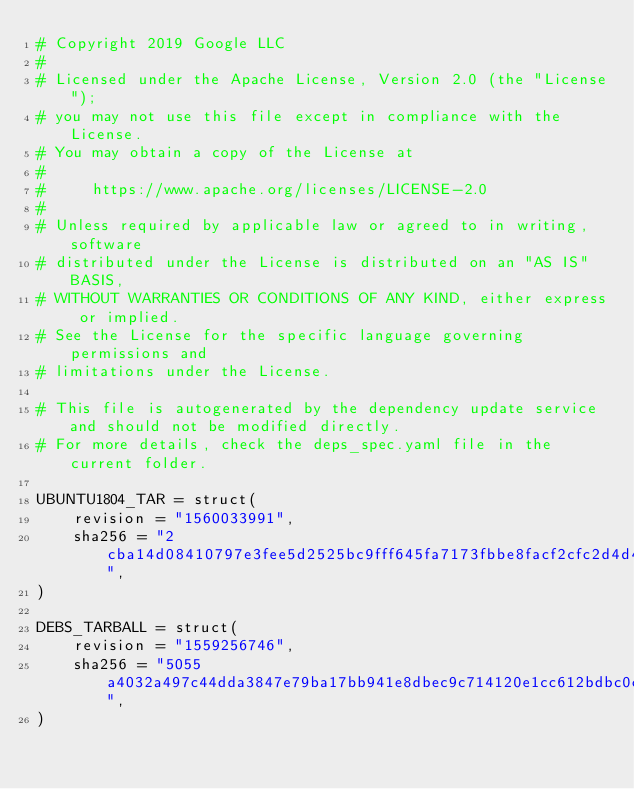Convert code to text. <code><loc_0><loc_0><loc_500><loc_500><_Python_># Copyright 2019 Google LLC
#
# Licensed under the Apache License, Version 2.0 (the "License");
# you may not use this file except in compliance with the License.
# You may obtain a copy of the License at
#
#     https://www.apache.org/licenses/LICENSE-2.0
#
# Unless required by applicable law or agreed to in writing, software
# distributed under the License is distributed on an "AS IS" BASIS,
# WITHOUT WARRANTIES OR CONDITIONS OF ANY KIND, either express or implied.
# See the License for the specific language governing permissions and
# limitations under the License.

# This file is autogenerated by the dependency update service and should not be modified directly.
# For more details, check the deps_spec.yaml file in the current folder.

UBUNTU1804_TAR = struct(
    revision = "1560033991",
    sha256 = "2cba14d08410797e3fee5d2525bc9fff645fa7173fbbe8facf2cfc2d4d47c5bf",
)

DEBS_TARBALL = struct(
    revision = "1559256746",
    sha256 = "5055a4032a497c44dda3847e79ba17bb941e8dbec9c714120e1cc612bdbc0c14",
)
</code> 